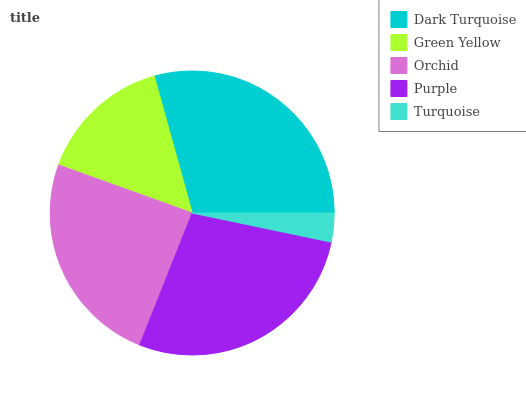Is Turquoise the minimum?
Answer yes or no. Yes. Is Dark Turquoise the maximum?
Answer yes or no. Yes. Is Green Yellow the minimum?
Answer yes or no. No. Is Green Yellow the maximum?
Answer yes or no. No. Is Dark Turquoise greater than Green Yellow?
Answer yes or no. Yes. Is Green Yellow less than Dark Turquoise?
Answer yes or no. Yes. Is Green Yellow greater than Dark Turquoise?
Answer yes or no. No. Is Dark Turquoise less than Green Yellow?
Answer yes or no. No. Is Orchid the high median?
Answer yes or no. Yes. Is Orchid the low median?
Answer yes or no. Yes. Is Turquoise the high median?
Answer yes or no. No. Is Green Yellow the low median?
Answer yes or no. No. 